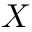<formula> <loc_0><loc_0><loc_500><loc_500>X</formula> 